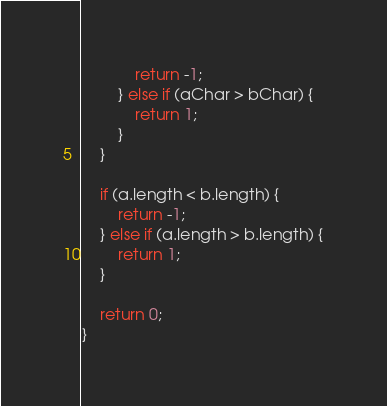<code> <loc_0><loc_0><loc_500><loc_500><_JavaScript_>            return -1;
        } else if (aChar > bChar) {
            return 1;
        }
    }

    if (a.length < b.length) {
        return -1;
    } else if (a.length > b.length) {
        return 1;
    }

    return 0;
}
</code> 